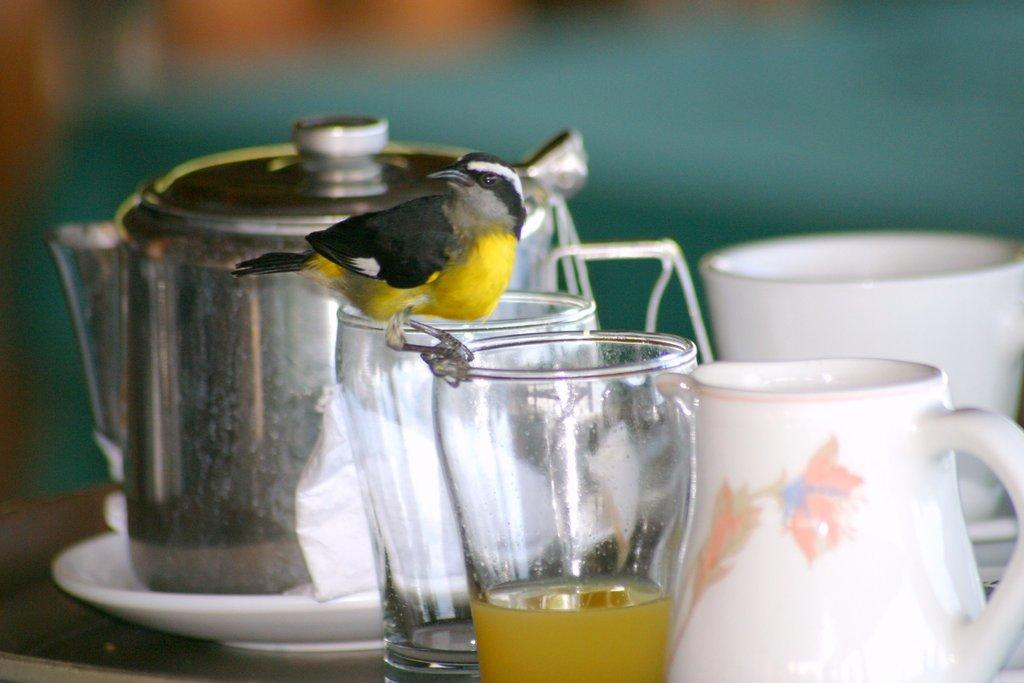What is the main object in the image? There is a tea pot in the image. What other objects are visible in the image? There are glasses and cups in the image. Can you describe the unique feature of one of the glasses? There is a bird on one of the glasses. How would you describe the overall appearance of the image? The background of the image is blurry. What is the primary piece of furniture in the image? There is a table at the bottom of the image. What type of food is being served on the table in the image? There is no food visible in the image; it primarily features a tea pot, glasses, cups, and a bird on one of the glasses. 